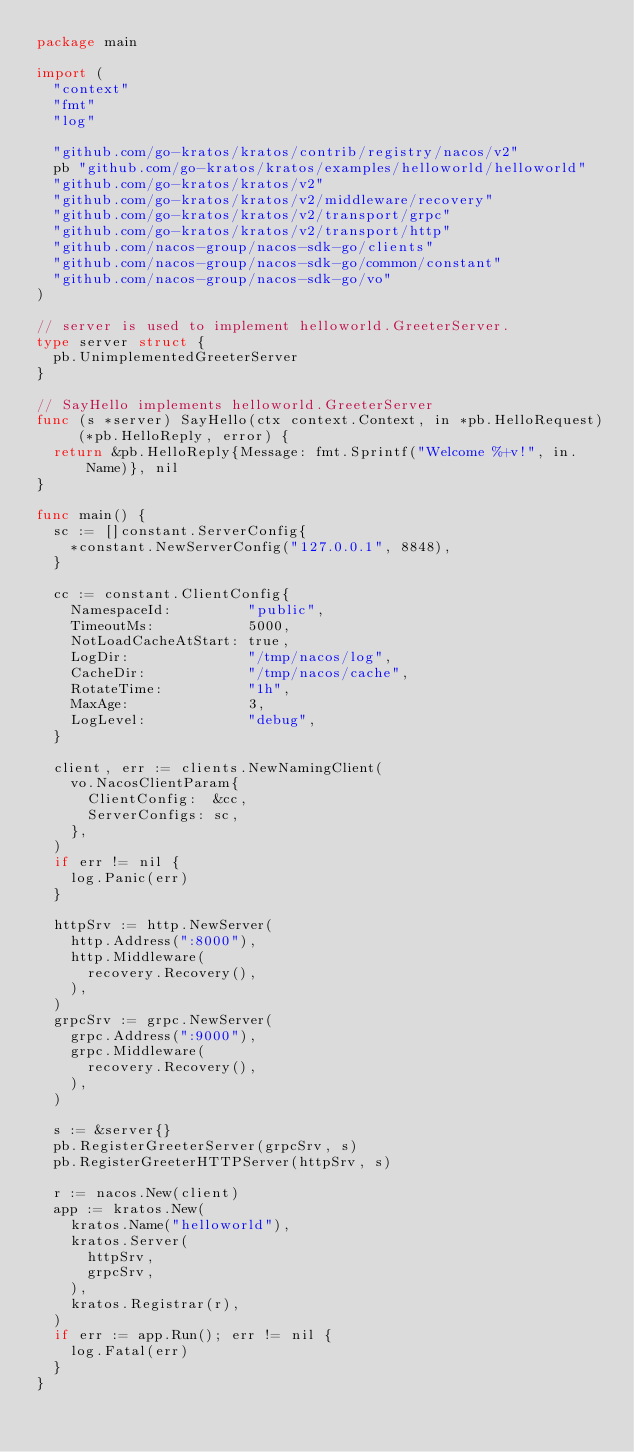Convert code to text. <code><loc_0><loc_0><loc_500><loc_500><_Go_>package main

import (
	"context"
	"fmt"
	"log"

	"github.com/go-kratos/kratos/contrib/registry/nacos/v2"
	pb "github.com/go-kratos/kratos/examples/helloworld/helloworld"
	"github.com/go-kratos/kratos/v2"
	"github.com/go-kratos/kratos/v2/middleware/recovery"
	"github.com/go-kratos/kratos/v2/transport/grpc"
	"github.com/go-kratos/kratos/v2/transport/http"
	"github.com/nacos-group/nacos-sdk-go/clients"
	"github.com/nacos-group/nacos-sdk-go/common/constant"
	"github.com/nacos-group/nacos-sdk-go/vo"
)

// server is used to implement helloworld.GreeterServer.
type server struct {
	pb.UnimplementedGreeterServer
}

// SayHello implements helloworld.GreeterServer
func (s *server) SayHello(ctx context.Context, in *pb.HelloRequest) (*pb.HelloReply, error) {
	return &pb.HelloReply{Message: fmt.Sprintf("Welcome %+v!", in.Name)}, nil
}

func main() {
	sc := []constant.ServerConfig{
		*constant.NewServerConfig("127.0.0.1", 8848),
	}

	cc := constant.ClientConfig{
		NamespaceId:         "public",
		TimeoutMs:           5000,
		NotLoadCacheAtStart: true,
		LogDir:              "/tmp/nacos/log",
		CacheDir:            "/tmp/nacos/cache",
		RotateTime:          "1h",
		MaxAge:              3,
		LogLevel:            "debug",
	}

	client, err := clients.NewNamingClient(
		vo.NacosClientParam{
			ClientConfig:  &cc,
			ServerConfigs: sc,
		},
	)
	if err != nil {
		log.Panic(err)
	}

	httpSrv := http.NewServer(
		http.Address(":8000"),
		http.Middleware(
			recovery.Recovery(),
		),
	)
	grpcSrv := grpc.NewServer(
		grpc.Address(":9000"),
		grpc.Middleware(
			recovery.Recovery(),
		),
	)

	s := &server{}
	pb.RegisterGreeterServer(grpcSrv, s)
	pb.RegisterGreeterHTTPServer(httpSrv, s)

	r := nacos.New(client)
	app := kratos.New(
		kratos.Name("helloworld"),
		kratos.Server(
			httpSrv,
			grpcSrv,
		),
		kratos.Registrar(r),
	)
	if err := app.Run(); err != nil {
		log.Fatal(err)
	}
}
</code> 